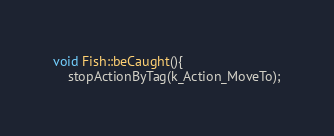<code> <loc_0><loc_0><loc_500><loc_500><_C++_>void Fish::beCaught(){
	stopActionByTag(k_Action_MoveTo);</code> 